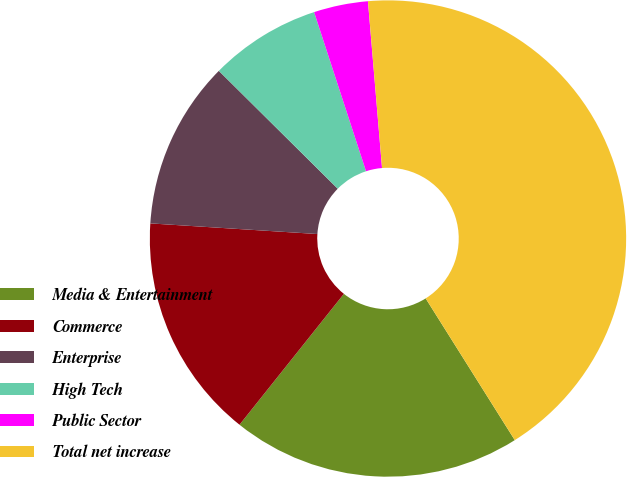Convert chart to OTSL. <chart><loc_0><loc_0><loc_500><loc_500><pie_chart><fcel>Media & Entertainment<fcel>Commerce<fcel>Enterprise<fcel>High Tech<fcel>Public Sector<fcel>Total net increase<nl><fcel>19.65%<fcel>15.3%<fcel>11.42%<fcel>7.55%<fcel>3.68%<fcel>42.41%<nl></chart> 